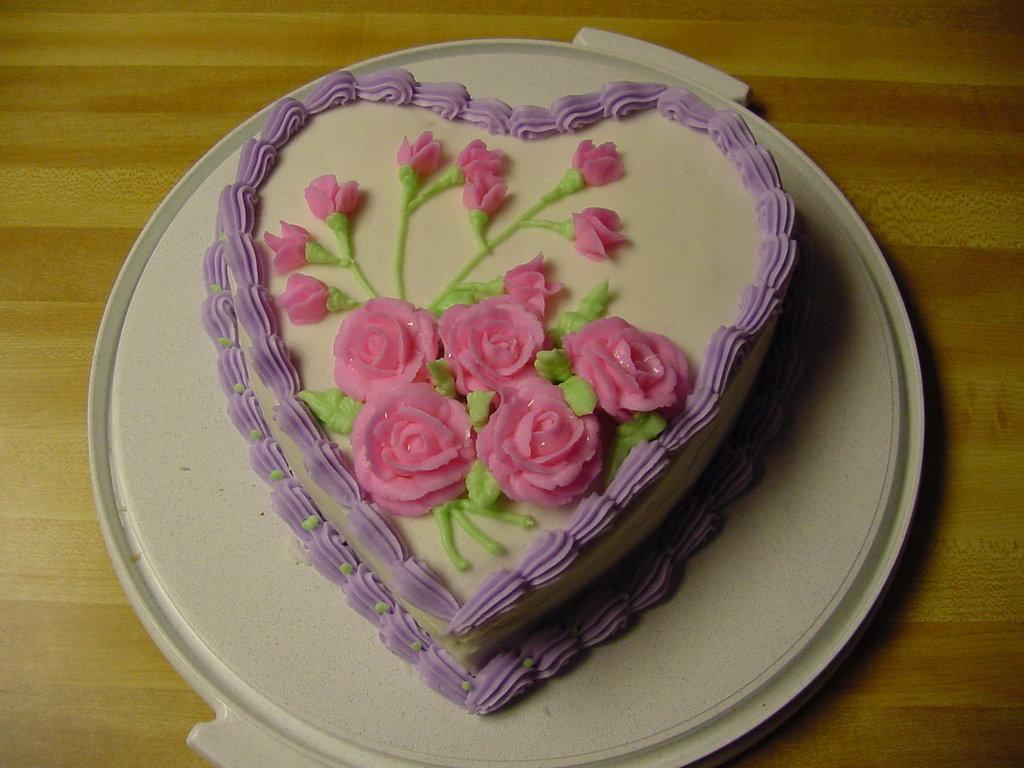What is the main subject of the image? There is a cake in the image. How is the cake positioned in the image? The cake is placed on a plate. Where is the plate with the cake located? The plate with the cake is on a table. What type of nerve can be seen in the image? There is no nerve present in the image; it features a cake on a plate on a table. 